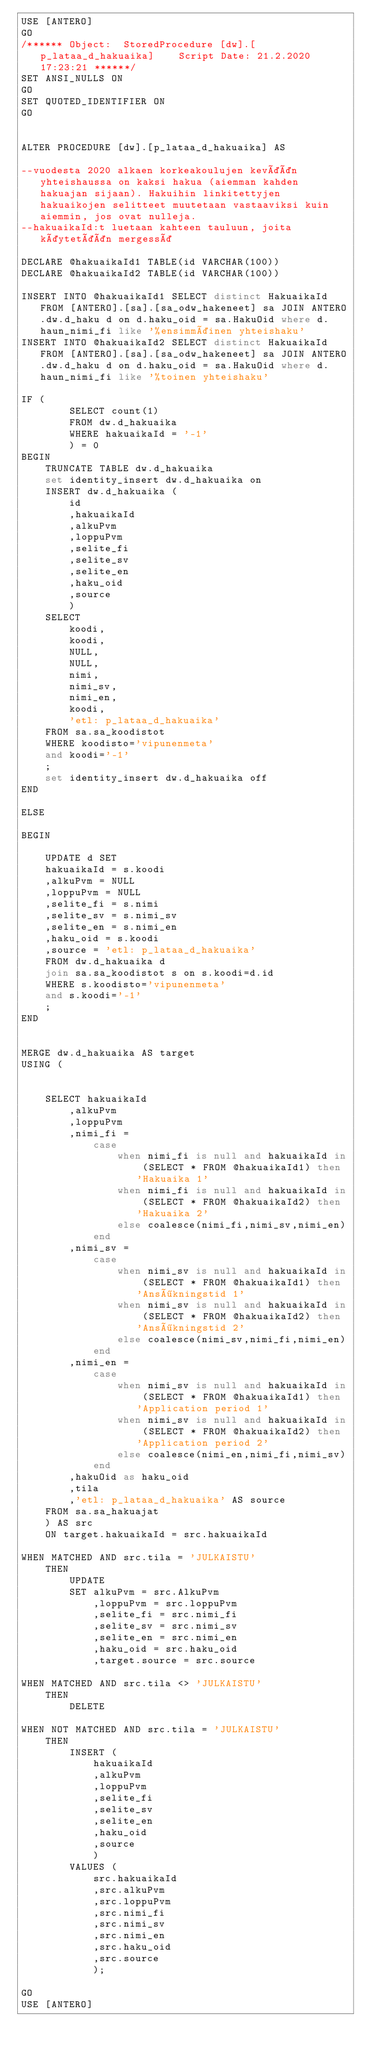<code> <loc_0><loc_0><loc_500><loc_500><_SQL_>USE [ANTERO]
GO
/****** Object:  StoredProcedure [dw].[p_lataa_d_hakuaika]    Script Date: 21.2.2020 17:23:21 ******/
SET ANSI_NULLS ON
GO
SET QUOTED_IDENTIFIER ON
GO


ALTER PROCEDURE [dw].[p_lataa_d_hakuaika] AS

--vuodesta 2020 alkaen korkeakoulujen kevään yhteishaussa on kaksi hakua (aiemman kahden hakuajan sijaan). Hakuihin linkitettyjen hakuaikojen selitteet muutetaan vastaaviksi kuin aiemmin, jos ovat nulleja.
--hakuaikaId:t luetaan kahteen tauluun, joita käytetään mergessä

DECLARE @hakuaikaId1 TABLE(id VARCHAR(100))
DECLARE @hakuaikaId2 TABLE(id VARCHAR(100))

INSERT INTO @hakuaikaId1 SELECT distinct HakuaikaId FROM [ANTERO].[sa].[sa_odw_hakeneet] sa JOIN ANTERO.dw.d_haku d on d.haku_oid = sa.HakuOid where d.haun_nimi_fi like '%ensimmäinen yhteishaku'
INSERT INTO @hakuaikaId2 SELECT distinct HakuaikaId FROM [ANTERO].[sa].[sa_odw_hakeneet] sa JOIN ANTERO.dw.d_haku d on d.haku_oid = sa.HakuOid where d.haun_nimi_fi like '%toinen yhteishaku'

IF (
		SELECT count(1)
		FROM dw.d_hakuaika
		WHERE hakuaikaId = '-1'
		) = 0
BEGIN
	TRUNCATE TABLE dw.d_hakuaika
	set identity_insert dw.d_hakuaika on
	INSERT dw.d_hakuaika (
		id
		,hakuaikaId
		,alkuPvm
		,loppuPvm
		,selite_fi
		,selite_sv
		,selite_en
		,haku_oid
		,source
		)
	SELECT
		koodi,
		koodi,
		NULL,
		NULL,
		nimi,
		nimi_sv,
		nimi_en,
		koodi,
		'etl: p_lataa_d_hakuaika'
	FROM sa.sa_koodistot
	WHERE koodisto='vipunenmeta'
	and koodi='-1'
	;
	set identity_insert dw.d_hakuaika off
END

ELSE

BEGIN

	UPDATE d SET
	hakuaikaId = s.koodi
	,alkuPvm = NULL
	,loppuPvm = NULL
	,selite_fi = s.nimi
	,selite_sv = s.nimi_sv
	,selite_en = s.nimi_en
	,haku_oid = s.koodi
	,source = 'etl: p_lataa_d_hakuaika'
	FROM dw.d_hakuaika d
	join sa.sa_koodistot s on s.koodi=d.id
	WHERE s.koodisto='vipunenmeta'
	and s.koodi='-1'
	;
END


MERGE dw.d_hakuaika AS target
USING (
	

	SELECT hakuaikaId
		,alkuPvm
		,loppuPvm
		,nimi_fi = 
			case
				when nimi_fi is null and hakuaikaId in (SELECT * FROM @hakuaikaId1) then 'Hakuaika 1'
				when nimi_fi is null and hakuaikaId in (SELECT * FROM @hakuaikaId2) then 'Hakuaika 2'
				else coalesce(nimi_fi,nimi_sv,nimi_en) 
			end
		,nimi_sv =
			case
				when nimi_sv is null and hakuaikaId in (SELECT * FROM @hakuaikaId1) then 'Ansökningstid 1'
				when nimi_sv is null and hakuaikaId in (SELECT * FROM @hakuaikaId2) then 'Ansökningstid 2'
				else coalesce(nimi_sv,nimi_fi,nimi_en) 
			end
		,nimi_en = 
			case
				when nimi_sv is null and hakuaikaId in (SELECT * FROM @hakuaikaId1) then 'Application period 1'
				when nimi_sv is null and hakuaikaId in (SELECT * FROM @hakuaikaId2) then 'Application period 2'
				else coalesce(nimi_en,nimi_fi,nimi_sv) 
			end
		,hakuOid as haku_oid
		,tila
		,'etl: p_lataa_d_hakuaika' AS source
	FROM sa.sa_hakuajat
	) AS src
	ON target.hakuaikaId = src.hakuaikaId

WHEN MATCHED AND src.tila = 'JULKAISTU'
	THEN
		UPDATE
		SET alkuPvm = src.AlkuPvm
			,loppuPvm = src.loppuPvm
			,selite_fi = src.nimi_fi
			,selite_sv = src.nimi_sv
			,selite_en = src.nimi_en
			,haku_oid = src.haku_oid
			,target.source = src.source

WHEN MATCHED AND src.tila <> 'JULKAISTU'
	THEN
		DELETE
	
WHEN NOT MATCHED AND src.tila = 'JULKAISTU'
	THEN
		INSERT (
			hakuaikaId
			,alkuPvm
			,loppuPvm
			,selite_fi
			,selite_sv
			,selite_en
			,haku_oid
			,source
			)
		VALUES (
			src.hakuaikaId
			,src.alkuPvm
			,src.loppuPvm
			,src.nimi_fi
			,src.nimi_sv
			,src.nimi_en
			,src.haku_oid
			,src.source
			);
			
GO
USE [ANTERO]</code> 